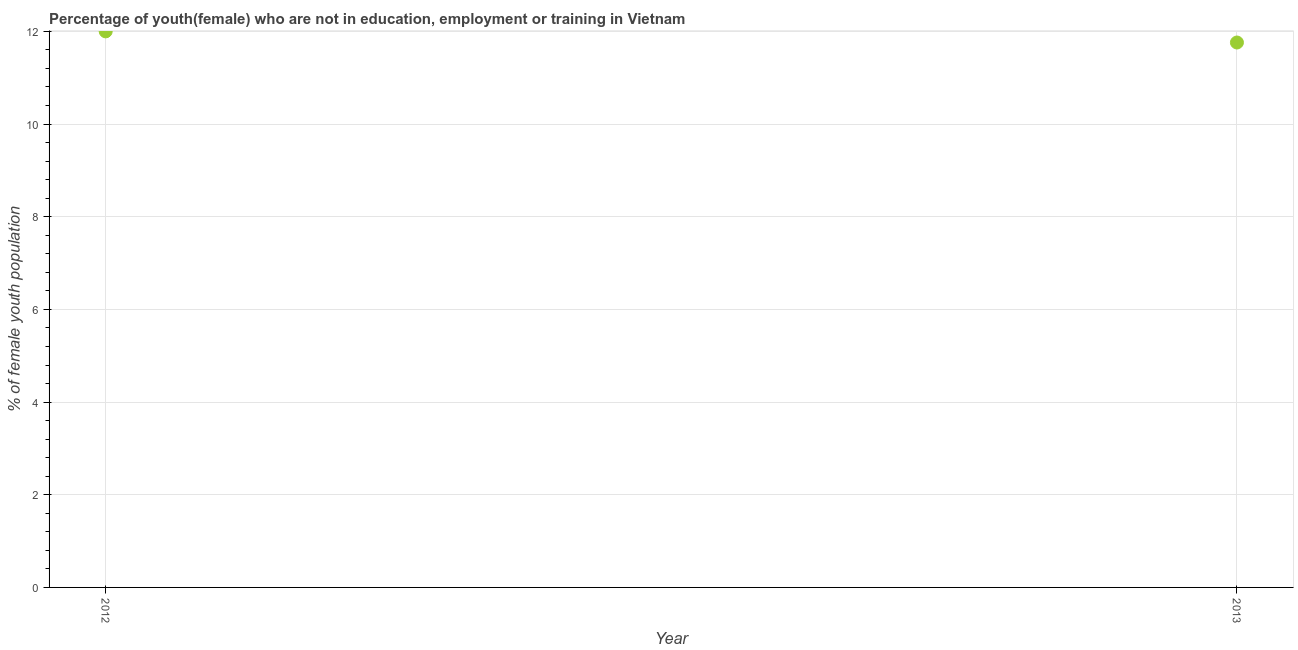What is the unemployed female youth population in 2013?
Give a very brief answer. 11.76. Across all years, what is the maximum unemployed female youth population?
Offer a terse response. 12. Across all years, what is the minimum unemployed female youth population?
Provide a succinct answer. 11.76. What is the sum of the unemployed female youth population?
Give a very brief answer. 23.76. What is the difference between the unemployed female youth population in 2012 and 2013?
Keep it short and to the point. 0.24. What is the average unemployed female youth population per year?
Give a very brief answer. 11.88. What is the median unemployed female youth population?
Provide a succinct answer. 11.88. What is the ratio of the unemployed female youth population in 2012 to that in 2013?
Provide a short and direct response. 1.02. How many dotlines are there?
Give a very brief answer. 1. What is the difference between two consecutive major ticks on the Y-axis?
Keep it short and to the point. 2. Are the values on the major ticks of Y-axis written in scientific E-notation?
Make the answer very short. No. Does the graph contain any zero values?
Offer a very short reply. No. Does the graph contain grids?
Make the answer very short. Yes. What is the title of the graph?
Give a very brief answer. Percentage of youth(female) who are not in education, employment or training in Vietnam. What is the label or title of the X-axis?
Your answer should be very brief. Year. What is the label or title of the Y-axis?
Your answer should be compact. % of female youth population. What is the % of female youth population in 2012?
Your response must be concise. 12. What is the % of female youth population in 2013?
Your response must be concise. 11.76. What is the difference between the % of female youth population in 2012 and 2013?
Your answer should be very brief. 0.24. 